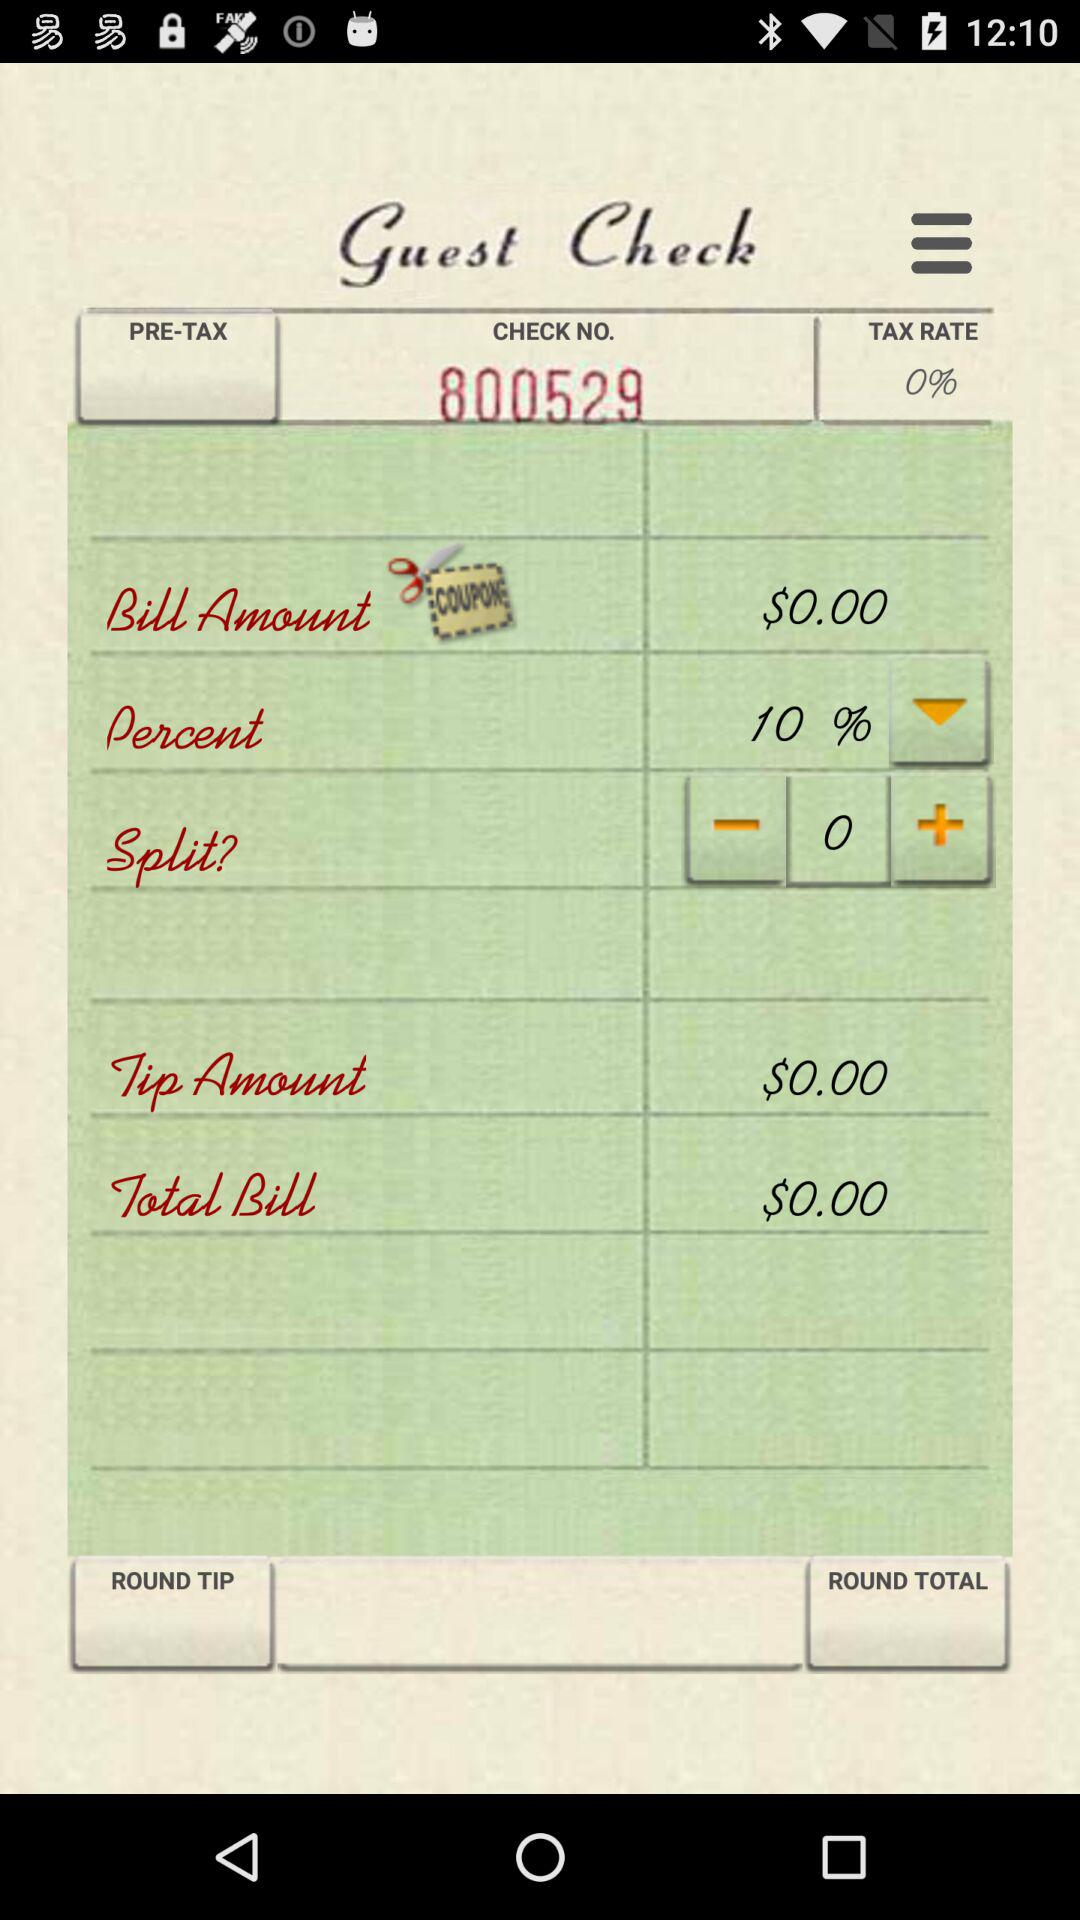What is the bill amount? The bill amount is $0. 